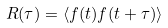Convert formula to latex. <formula><loc_0><loc_0><loc_500><loc_500>R ( \tau ) = \langle f ( t ) f ( t + \tau ) \rangle</formula> 